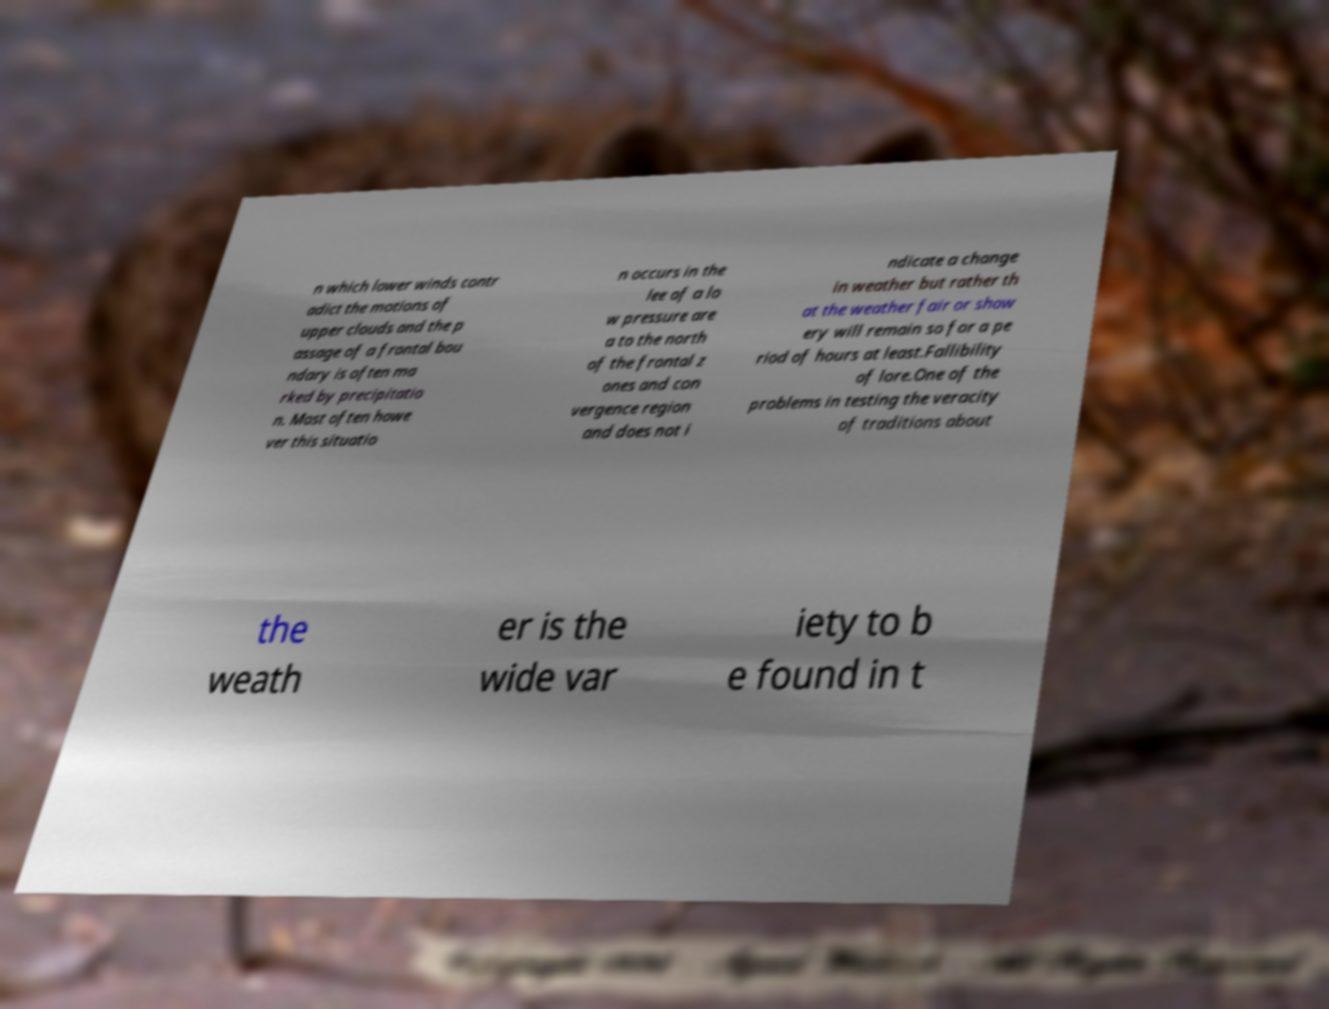I need the written content from this picture converted into text. Can you do that? n which lower winds contr adict the motions of upper clouds and the p assage of a frontal bou ndary is often ma rked by precipitatio n. Most often howe ver this situatio n occurs in the lee of a lo w pressure are a to the north of the frontal z ones and con vergence region and does not i ndicate a change in weather but rather th at the weather fair or show ery will remain so for a pe riod of hours at least.Fallibility of lore.One of the problems in testing the veracity of traditions about the weath er is the wide var iety to b e found in t 